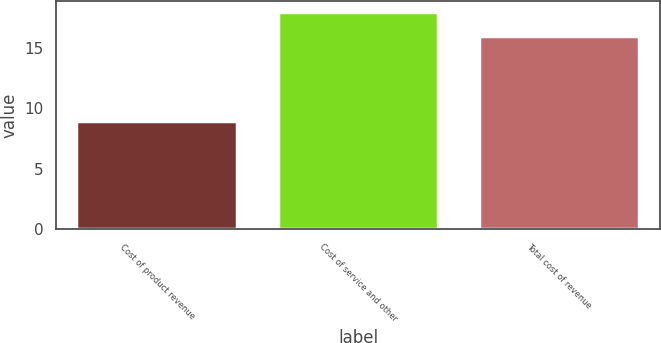Convert chart. <chart><loc_0><loc_0><loc_500><loc_500><bar_chart><fcel>Cost of product revenue<fcel>Cost of service and other<fcel>Total cost of revenue<nl><fcel>9<fcel>18<fcel>16<nl></chart> 